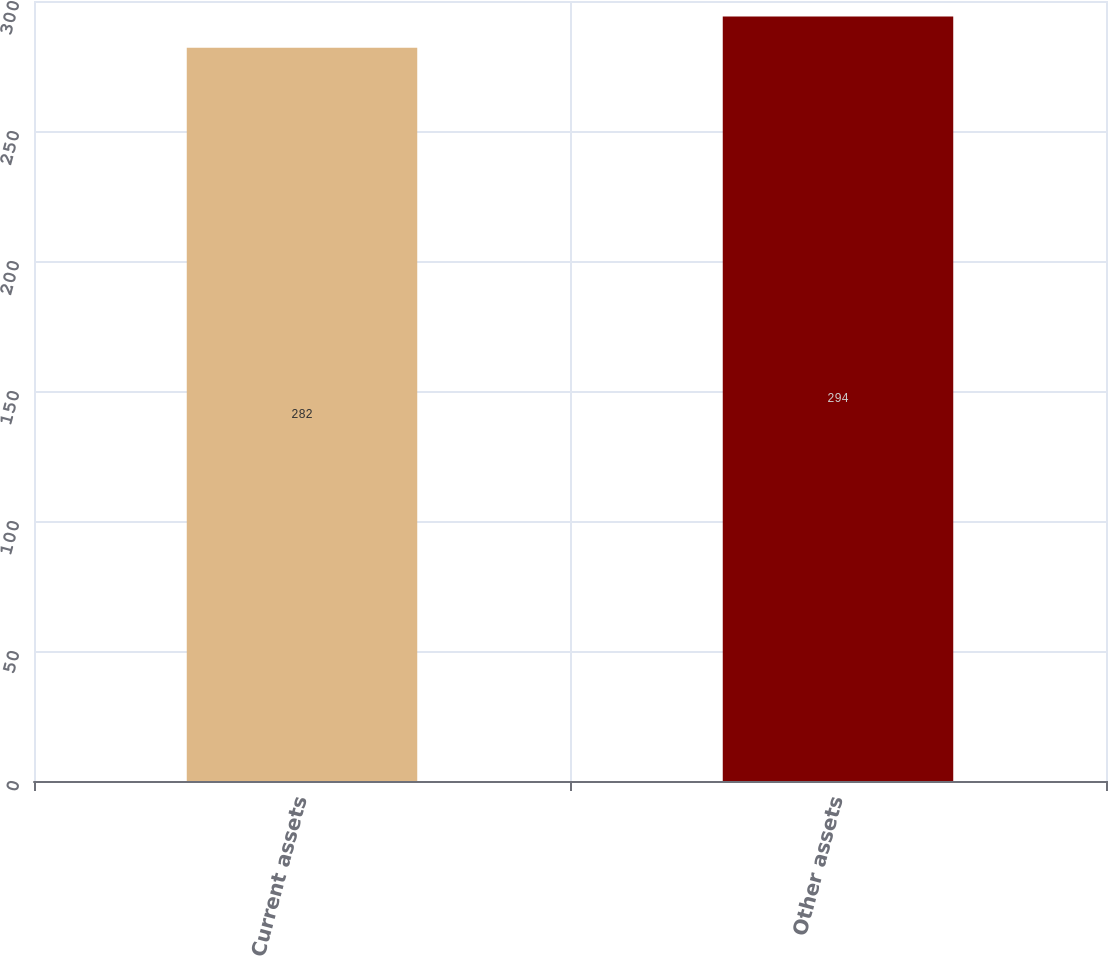Convert chart. <chart><loc_0><loc_0><loc_500><loc_500><bar_chart><fcel>Current assets<fcel>Other assets<nl><fcel>282<fcel>294<nl></chart> 